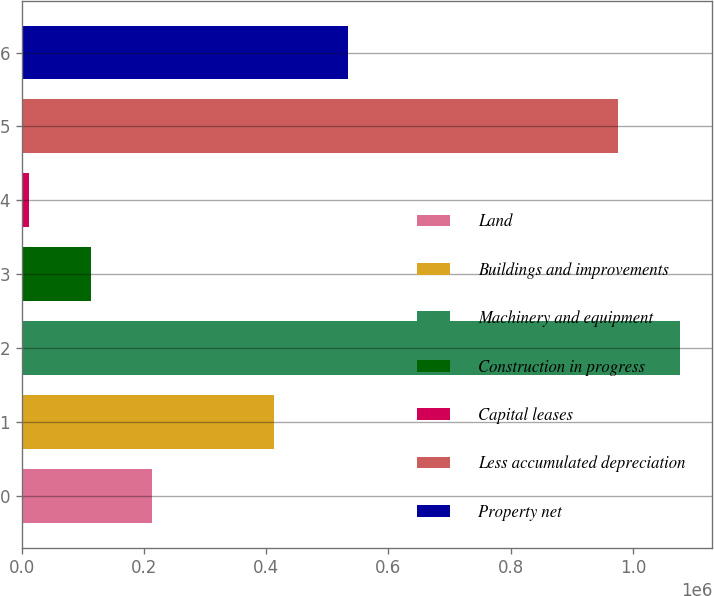Convert chart. <chart><loc_0><loc_0><loc_500><loc_500><bar_chart><fcel>Land<fcel>Buildings and improvements<fcel>Machinery and equipment<fcel>Construction in progress<fcel>Capital leases<fcel>Less accumulated depreciation<fcel>Property net<nl><fcel>212632<fcel>412326<fcel>1.07631e+06<fcel>112447<fcel>12262<fcel>976129<fcel>534286<nl></chart> 